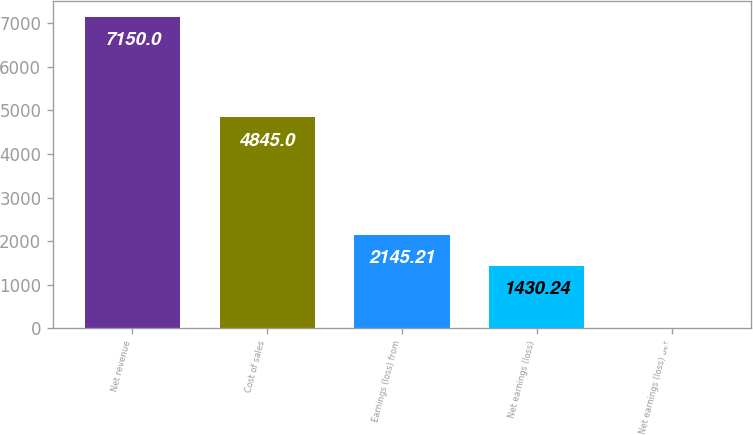Convert chart to OTSL. <chart><loc_0><loc_0><loc_500><loc_500><bar_chart><fcel>Net revenue<fcel>Cost of sales<fcel>Earnings (loss) from<fcel>Net earnings (loss)<fcel>Net earnings (loss) per<nl><fcel>7150<fcel>4845<fcel>2145.21<fcel>1430.24<fcel>0.3<nl></chart> 